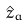Convert formula to latex. <formula><loc_0><loc_0><loc_500><loc_500>\hat { z } _ { a }</formula> 